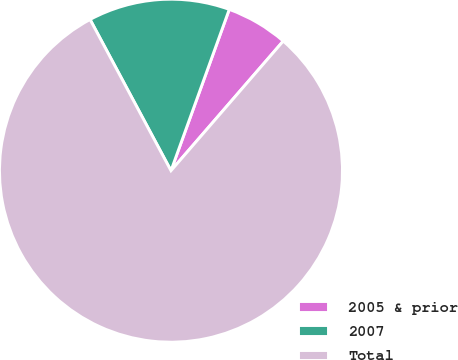Convert chart to OTSL. <chart><loc_0><loc_0><loc_500><loc_500><pie_chart><fcel>2005 & prior<fcel>2007<fcel>Total<nl><fcel>5.84%<fcel>13.34%<fcel>80.82%<nl></chart> 